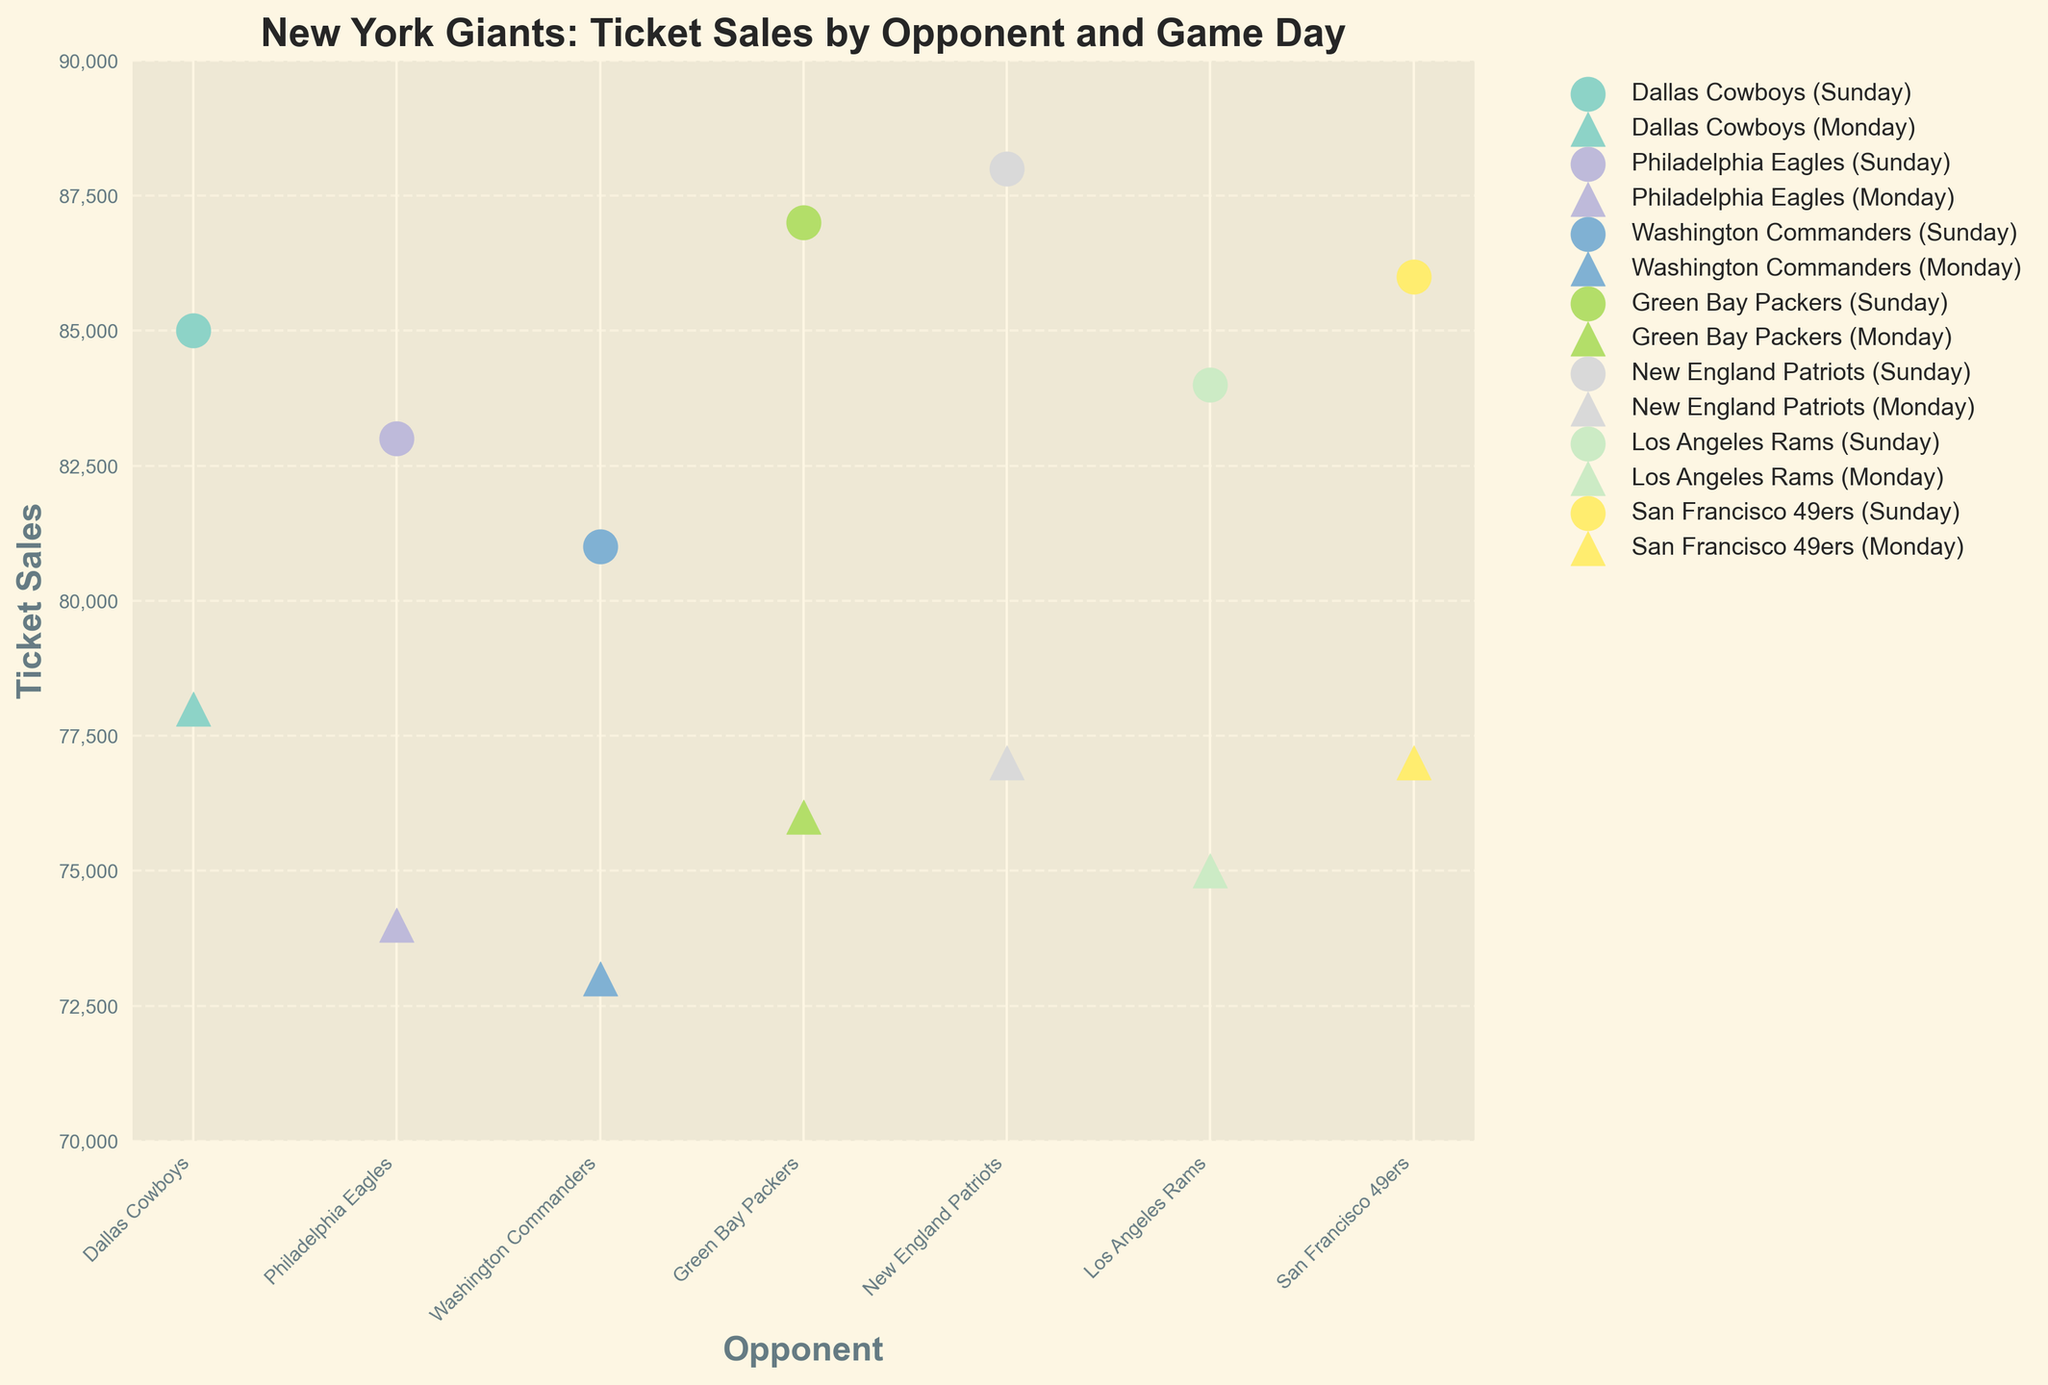What is the title of the plot? The title of the plot is usually displayed at the top of the figure to provide a summary of its content. It helps understand what the figure represents.
Answer: New York Giants: Ticket Sales by Opponent and Game Day What are the labels of the x-axis and y-axis? The labels of the axes are important for identifying what the axes represent in the context of the data. Inspect the figure to locate these labels.
Answer: Opponent, Ticket Sales How many opponents are compared in the figure? Count the unique labels on the x-axis to find the number of different opponents featured in the visual representation.
Answer: 7 Which opponent had the highest ticket sales on Sunday? Look at the scatter points marked for each opponent on Sunday and identify the one with the highest y-axis value, indicating the highest ticket sales.
Answer: New England Patriots Which opponent had the lowest ticket sales on Monday? Check the scatter points marked for each opponent on Monday and identify the one with the lowest y-axis value, indicating the lowest ticket sales.
Answer: Washington Commanders What is the average ticket sales for the Dallas Cowboys over both game days? Add the ticket sales for Dallas Cowboys on Sunday and Monday, then divide by 2 to get the average. (85000 + 78000) / 2 = 81500
Answer: 81500 How do ticket sales on Sundays compare to those on Mondays? Compare the overall trend of the y-axis values for Sundays (circles) versus Mondays (triangles).
Answer: Sundays generally have higher ticket sales than Mondays Which two teams had the most similar ticket sales on Sunday? Look at the scatter points for Sundays and find the two closest in value. The Green Bay Packers and the San Francisco 49ers both have close values (87000 and 86000 respectively).
Answer: Green Bay Packers and San Francisco 49ers Are there any opponents whose ticket sales are roughly equal on both Sundays and Mondays? Compare the pairs of scatter points (circle and triangle) for each opponent and identify pairs that have similar y-values.
Answer: Los Angeles Rams For which opponent was the difference between Sunday and Monday ticket sales the largest? Calculate the difference between Sunday and Monday ticket sales for each opponent and identify the largest discrepancy. New England Patriots: 88000 - 77000 = 11000
Answer: New England Patriots 